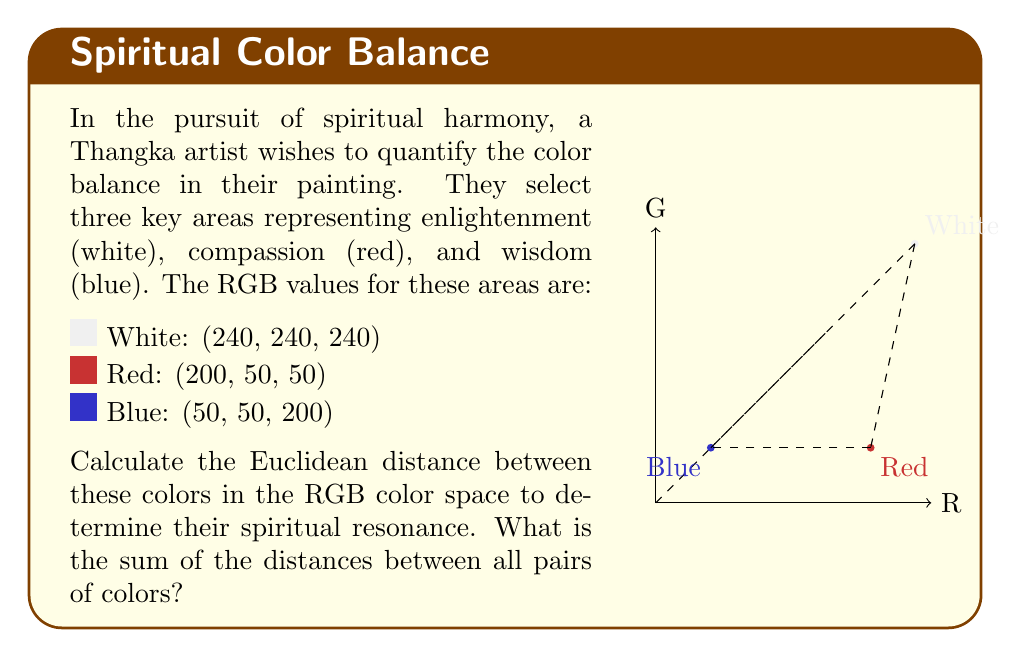Teach me how to tackle this problem. To calculate the Euclidean distance between colors in RGB space, we use the formula:

$$d = \sqrt{(R_1-R_2)^2 + (G_1-G_2)^2 + (B_1-B_2)^2}$$

Let's calculate the distance between each pair of colors:

1. White to Red:
   $$d_{WR} = \sqrt{(240-200)^2 + (240-50)^2 + (240-50)^2}$$
   $$= \sqrt{40^2 + 190^2 + 190^2} = \sqrt{1600 + 36100 + 36100} = \sqrt{73800} \approx 271.66$$

2. White to Blue:
   $$d_{WB} = \sqrt{(240-50)^2 + (240-50)^2 + (240-200)^2}$$
   $$= \sqrt{190^2 + 190^2 + 40^2} = \sqrt{36100 + 36100 + 1600} = \sqrt{73800} \approx 271.66$$

3. Red to Blue:
   $$d_{RB} = \sqrt{(200-50)^2 + (50-50)^2 + (50-200)^2}$$
   $$= \sqrt{150^2 + 0^2 + (-150)^2} = \sqrt{22500 + 0 + 22500} = \sqrt{45000} \approx 212.13$$

Now, we sum these distances:

$$\text{Total} = d_{WR} + d_{WB} + d_{RB} \approx 271.66 + 271.66 + 212.13 = 755.45$$

This sum represents the total spiritual resonance between the colors, with larger values indicating greater contrast and potentially more dynamic spiritual energy in the Thangka painting.
Answer: 755.45 